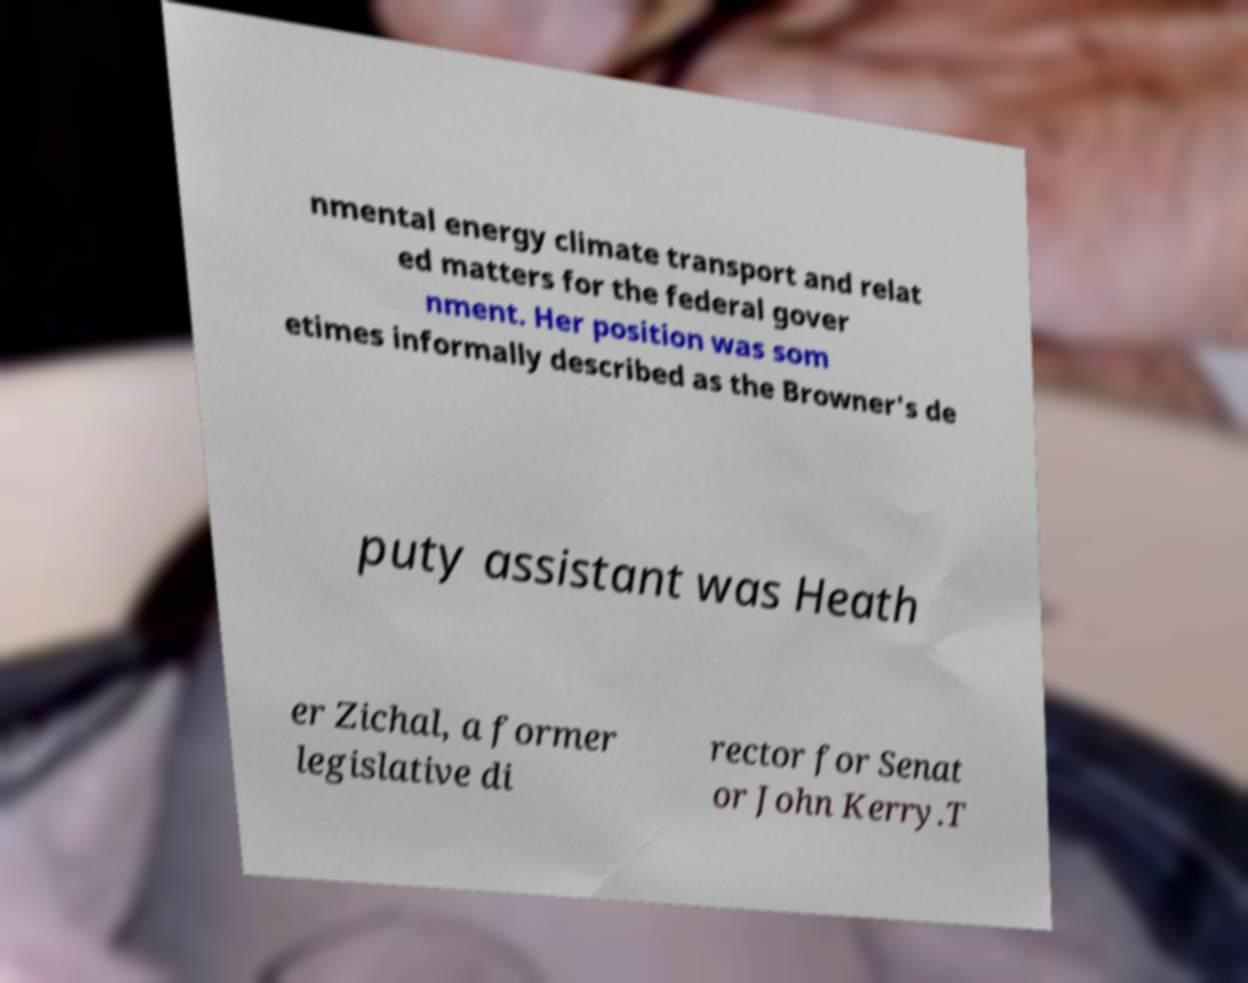There's text embedded in this image that I need extracted. Can you transcribe it verbatim? nmental energy climate transport and relat ed matters for the federal gover nment. Her position was som etimes informally described as the Browner's de puty assistant was Heath er Zichal, a former legislative di rector for Senat or John Kerry.T 